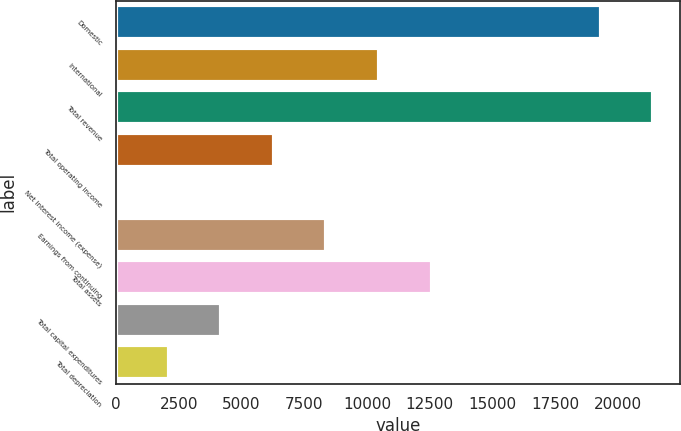Convert chart to OTSL. <chart><loc_0><loc_0><loc_500><loc_500><bar_chart><fcel>Domestic<fcel>International<fcel>Total revenue<fcel>Total operating income<fcel>Net interest income (expense)<fcel>Earnings from continuing<fcel>Total assets<fcel>Total capital expenditures<fcel>Total depreciation<nl><fcel>19303<fcel>10473.5<fcel>21396.9<fcel>6285.7<fcel>4<fcel>8379.6<fcel>12567.4<fcel>4191.8<fcel>2097.9<nl></chart> 